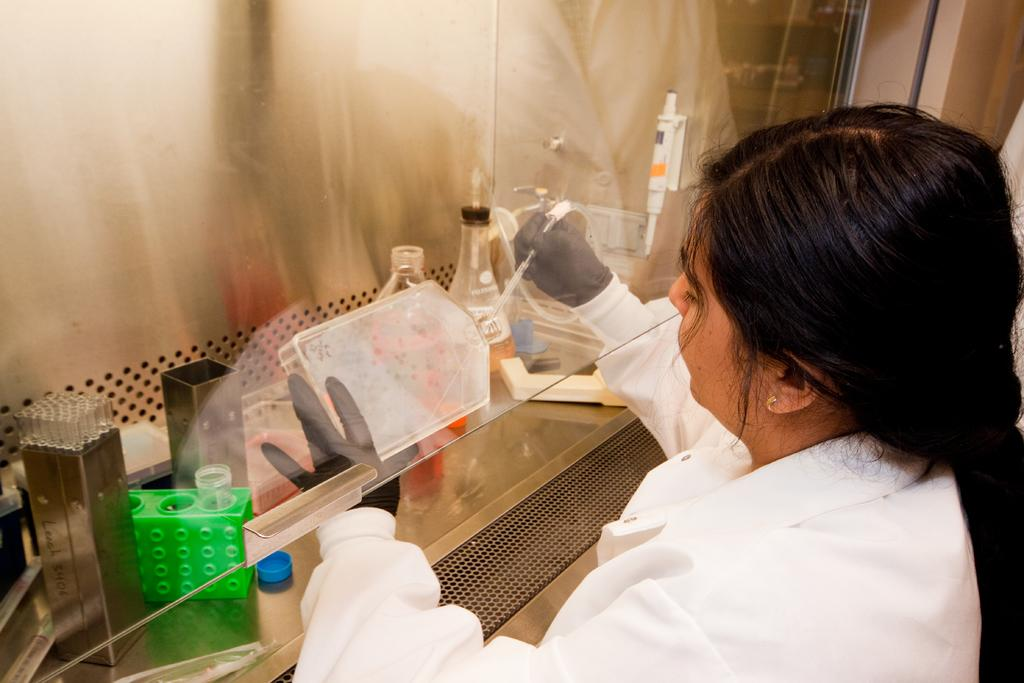Who is the main subject in the image? There is a woman in the image. What is the woman wearing? The woman is wearing a white dress. What is the woman doing in the image? The woman is doing some work. What can be seen near the woman in the image? There is a glass and a bottle in the image. Can you describe any other items in the image? There are other unspecified items in the image. What type of base is supporting the steam in the image? There is no base or steam present in the image. What position is the woman in while doing her work? The position of the woman cannot be determined from the image, as it only shows her from the front. 